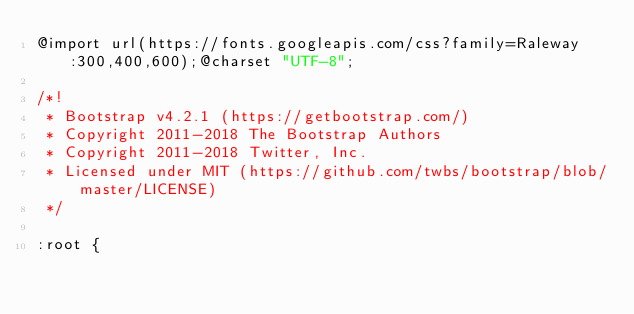<code> <loc_0><loc_0><loc_500><loc_500><_CSS_>@import url(https://fonts.googleapis.com/css?family=Raleway:300,400,600);@charset "UTF-8";

/*!
 * Bootstrap v4.2.1 (https://getbootstrap.com/)
 * Copyright 2011-2018 The Bootstrap Authors
 * Copyright 2011-2018 Twitter, Inc.
 * Licensed under MIT (https://github.com/twbs/bootstrap/blob/master/LICENSE)
 */

:root {</code> 